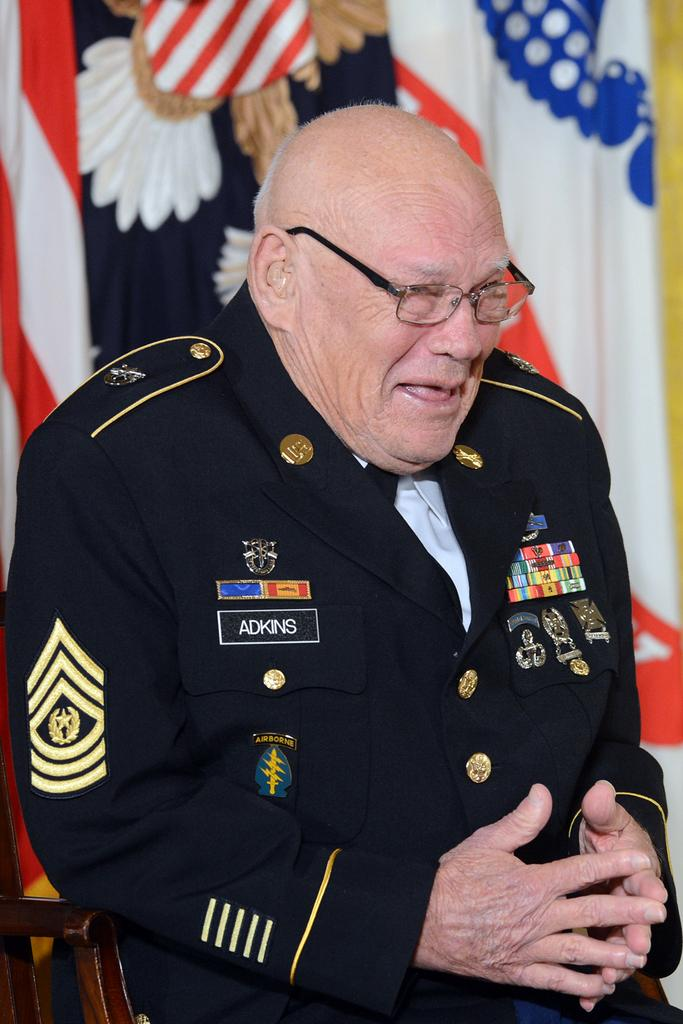What is present in the image? There is a person in the image. Can you describe the person's appearance? The person is wearing clothes and spectacles. What type of fowl can be seen eating an apple in the image? There is no fowl or apple present in the image; it features a person wearing clothes and spectacles. 